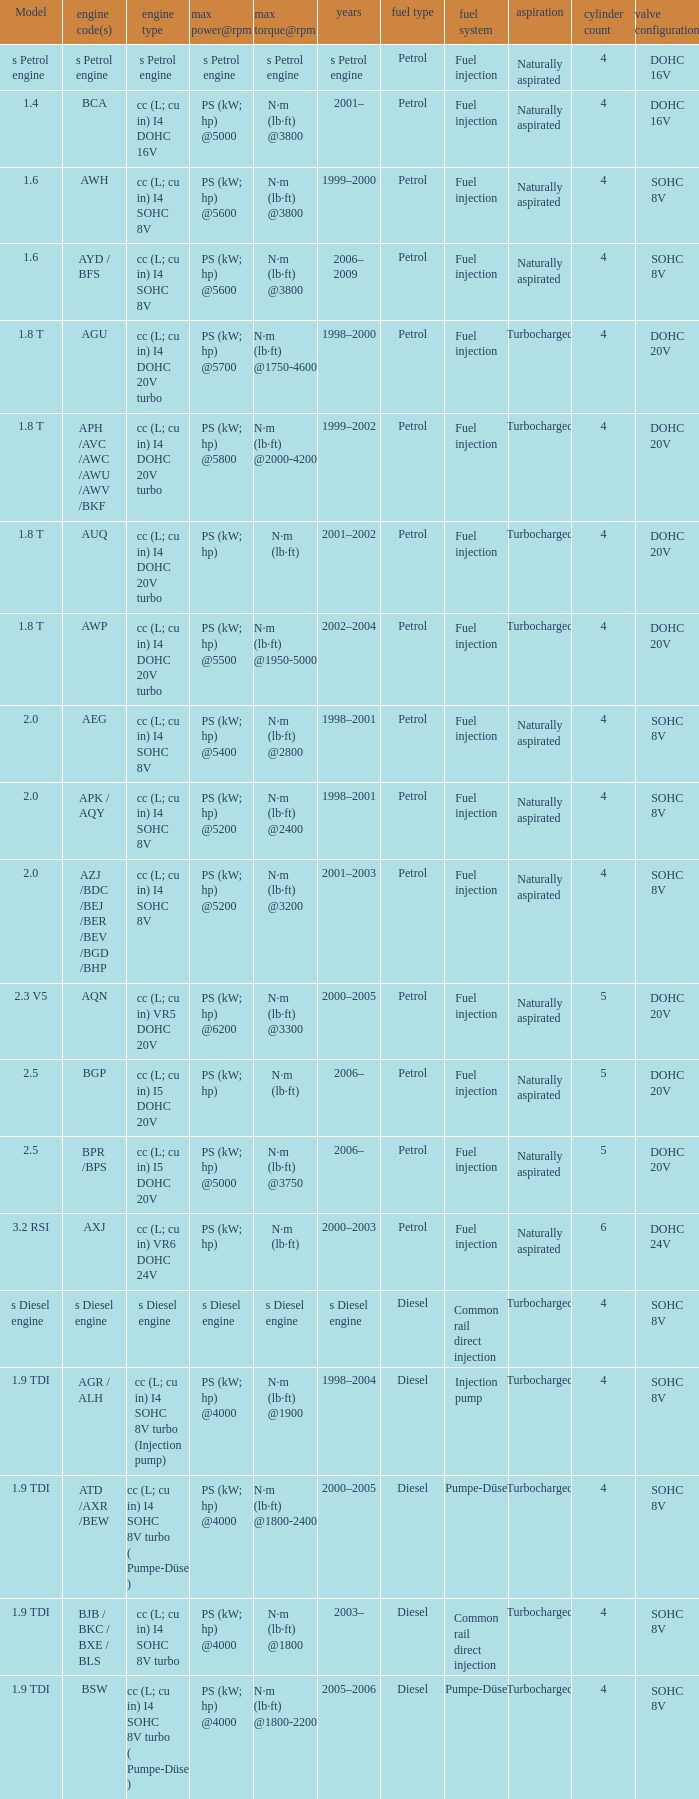What was the max torque@rpm of the engine which had the model 2.5  and a max power@rpm of ps (kw; hp) @5000? N·m (lb·ft) @3750. 